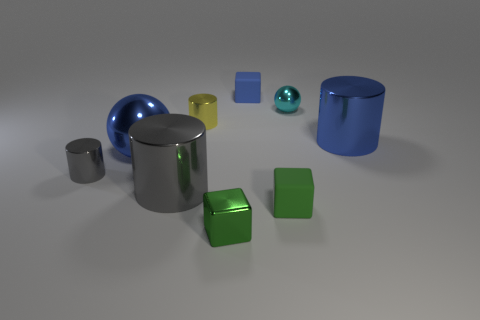There is a metal thing behind the tiny yellow thing; is its color the same as the large cylinder to the left of the small blue thing?
Your answer should be very brief. No. What color is the tiny object to the right of the green object to the right of the rubber object that is behind the yellow cylinder?
Provide a succinct answer. Cyan. Is there a tiny yellow object that is on the left side of the big cylinder on the left side of the cyan shiny ball?
Give a very brief answer. No. Does the big object that is in front of the small gray thing have the same shape as the blue rubber object?
Ensure brevity in your answer.  No. Is there any other thing that is the same shape as the yellow thing?
Keep it short and to the point. Yes. What number of blocks are tiny blue rubber things or green rubber objects?
Your answer should be very brief. 2. What number of green cubes are there?
Offer a terse response. 2. There is a ball right of the big shiny thing to the left of the big gray thing; what is its size?
Keep it short and to the point. Small. What number of other things are the same size as the shiny cube?
Your answer should be very brief. 5. There is a small metal cube; how many cyan balls are left of it?
Keep it short and to the point. 0. 